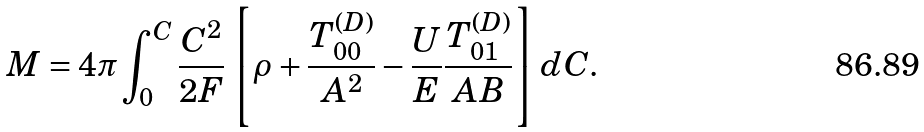<formula> <loc_0><loc_0><loc_500><loc_500>M = 4 \pi \int ^ { C } _ { 0 } \frac { C ^ { 2 } } { 2 F } \left [ \rho + \frac { T ^ { ( D ) } _ { 0 0 } } { A ^ { 2 } } - \frac { U } { E } \frac { T ^ { ( D ) } _ { 0 1 } } { A B } \right ] d C .</formula> 